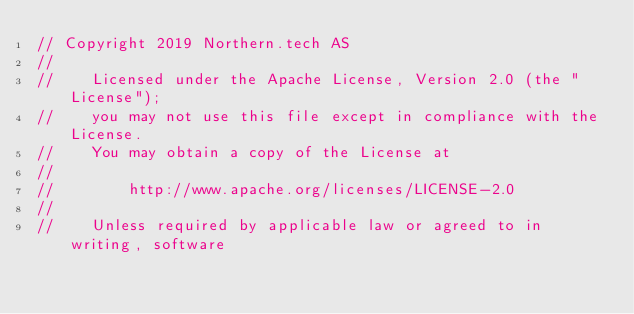<code> <loc_0><loc_0><loc_500><loc_500><_Go_>// Copyright 2019 Northern.tech AS
//
//    Licensed under the Apache License, Version 2.0 (the "License");
//    you may not use this file except in compliance with the License.
//    You may obtain a copy of the License at
//
//        http://www.apache.org/licenses/LICENSE-2.0
//
//    Unless required by applicable law or agreed to in writing, software</code> 